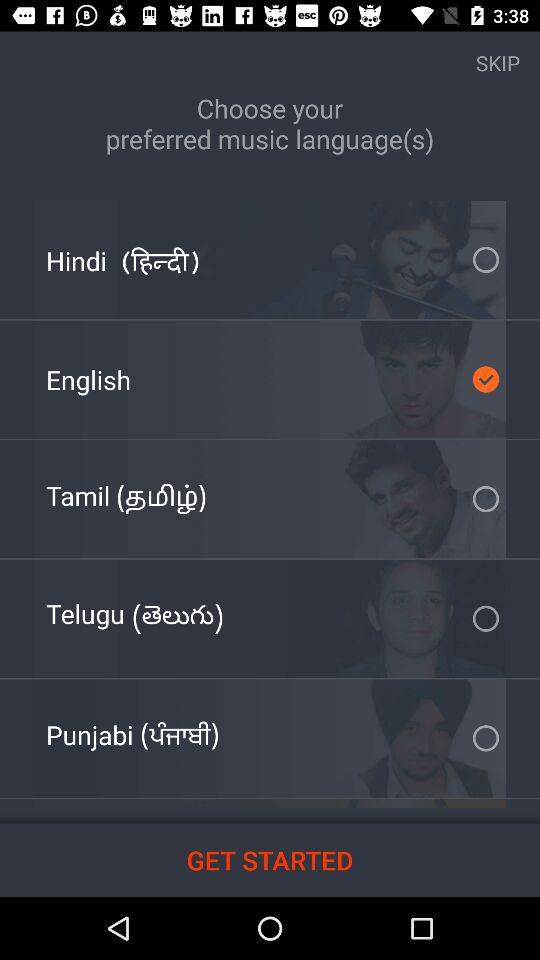How many languages are available to choose from?
Answer the question using a single word or phrase. 5 